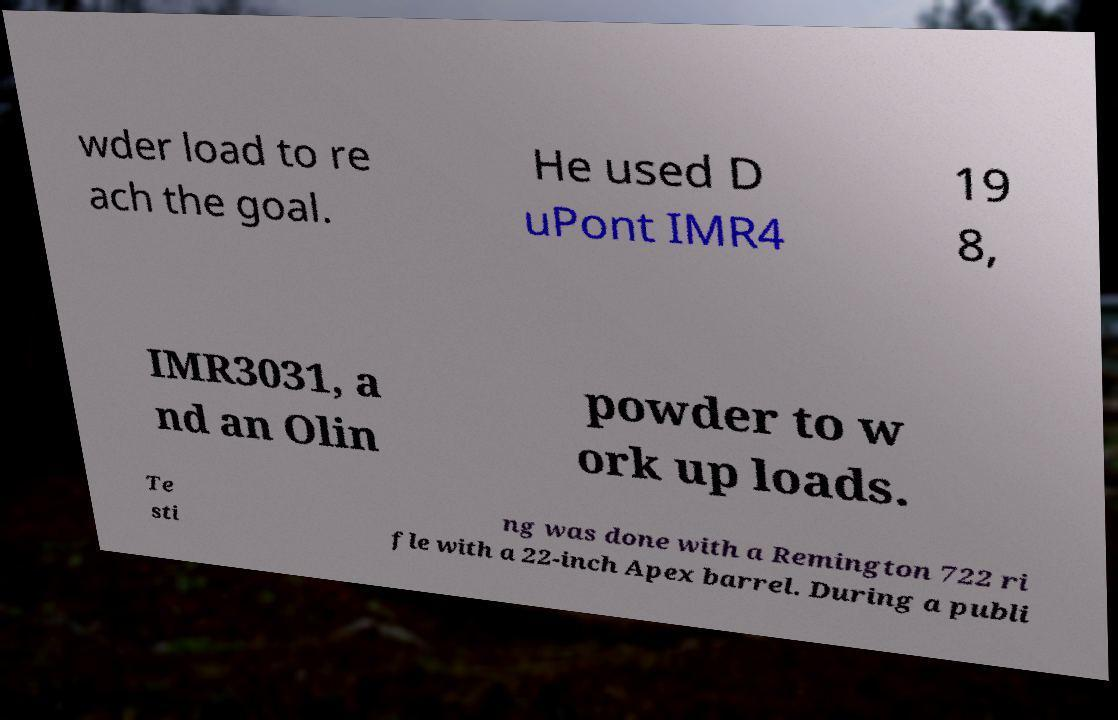What messages or text are displayed in this image? I need them in a readable, typed format. wder load to re ach the goal. He used D uPont IMR4 19 8, IMR3031, a nd an Olin powder to w ork up loads. Te sti ng was done with a Remington 722 ri fle with a 22-inch Apex barrel. During a publi 